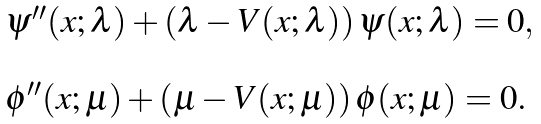<formula> <loc_0><loc_0><loc_500><loc_500>\begin{array} { l } \psi ^ { \prime \prime } ( x ; \lambda ) + \left ( \lambda - V ( x ; \lambda ) \right ) \psi ( x ; \lambda ) = 0 , \\ \\ \phi ^ { \prime \prime } ( x ; \mu ) + \left ( \mu - V ( x ; \mu ) \right ) \phi ( x ; \mu ) = 0 . \end{array}</formula> 